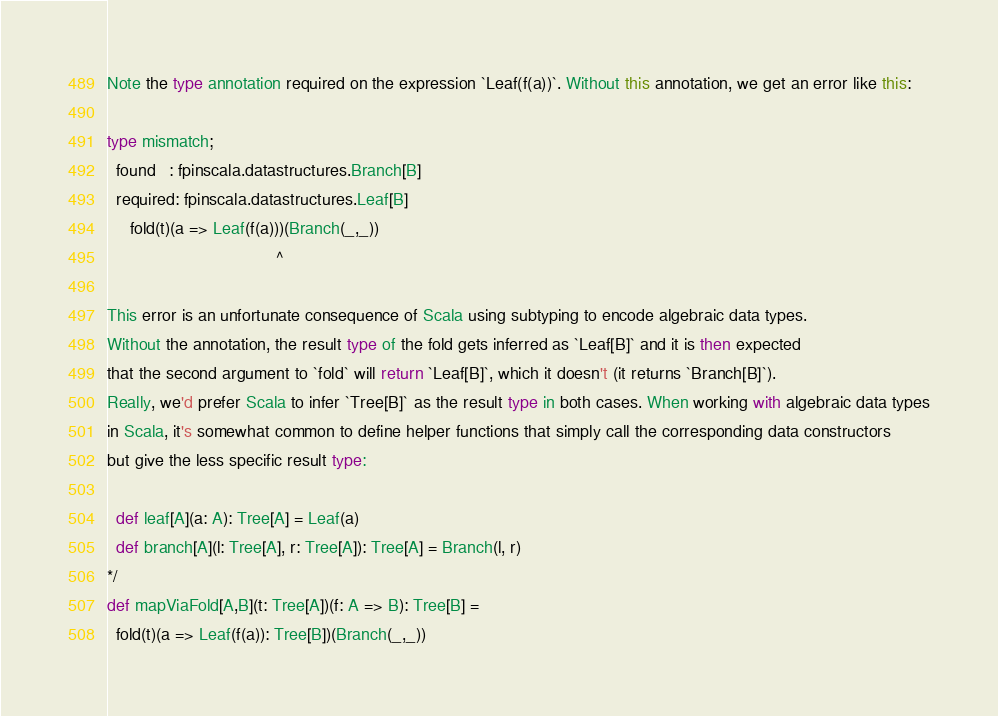Convert code to text. <code><loc_0><loc_0><loc_500><loc_500><_Scala_>Note the type annotation required on the expression `Leaf(f(a))`. Without this annotation, we get an error like this: 

type mismatch;
  found   : fpinscala.datastructures.Branch[B]
  required: fpinscala.datastructures.Leaf[B]
     fold(t)(a => Leaf(f(a)))(Branch(_,_))
                                    ^  

This error is an unfortunate consequence of Scala using subtyping to encode algebraic data types.
Without the annotation, the result type of the fold gets inferred as `Leaf[B]` and it is then expected
that the second argument to `fold` will return `Leaf[B]`, which it doesn't (it returns `Branch[B]`).
Really, we'd prefer Scala to infer `Tree[B]` as the result type in both cases. When working with algebraic data types
in Scala, it's somewhat common to define helper functions that simply call the corresponding data constructors
but give the less specific result type:
  
  def leaf[A](a: A): Tree[A] = Leaf(a)
  def branch[A](l: Tree[A], r: Tree[A]): Tree[A] = Branch(l, r)
*/
def mapViaFold[A,B](t: Tree[A])(f: A => B): Tree[B] = 
  fold(t)(a => Leaf(f(a)): Tree[B])(Branch(_,_))</code> 